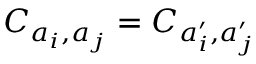Convert formula to latex. <formula><loc_0><loc_0><loc_500><loc_500>C _ { a _ { i } , a _ { j } } = C _ { a _ { i } ^ { \prime } , a _ { j } ^ { \prime } }</formula> 